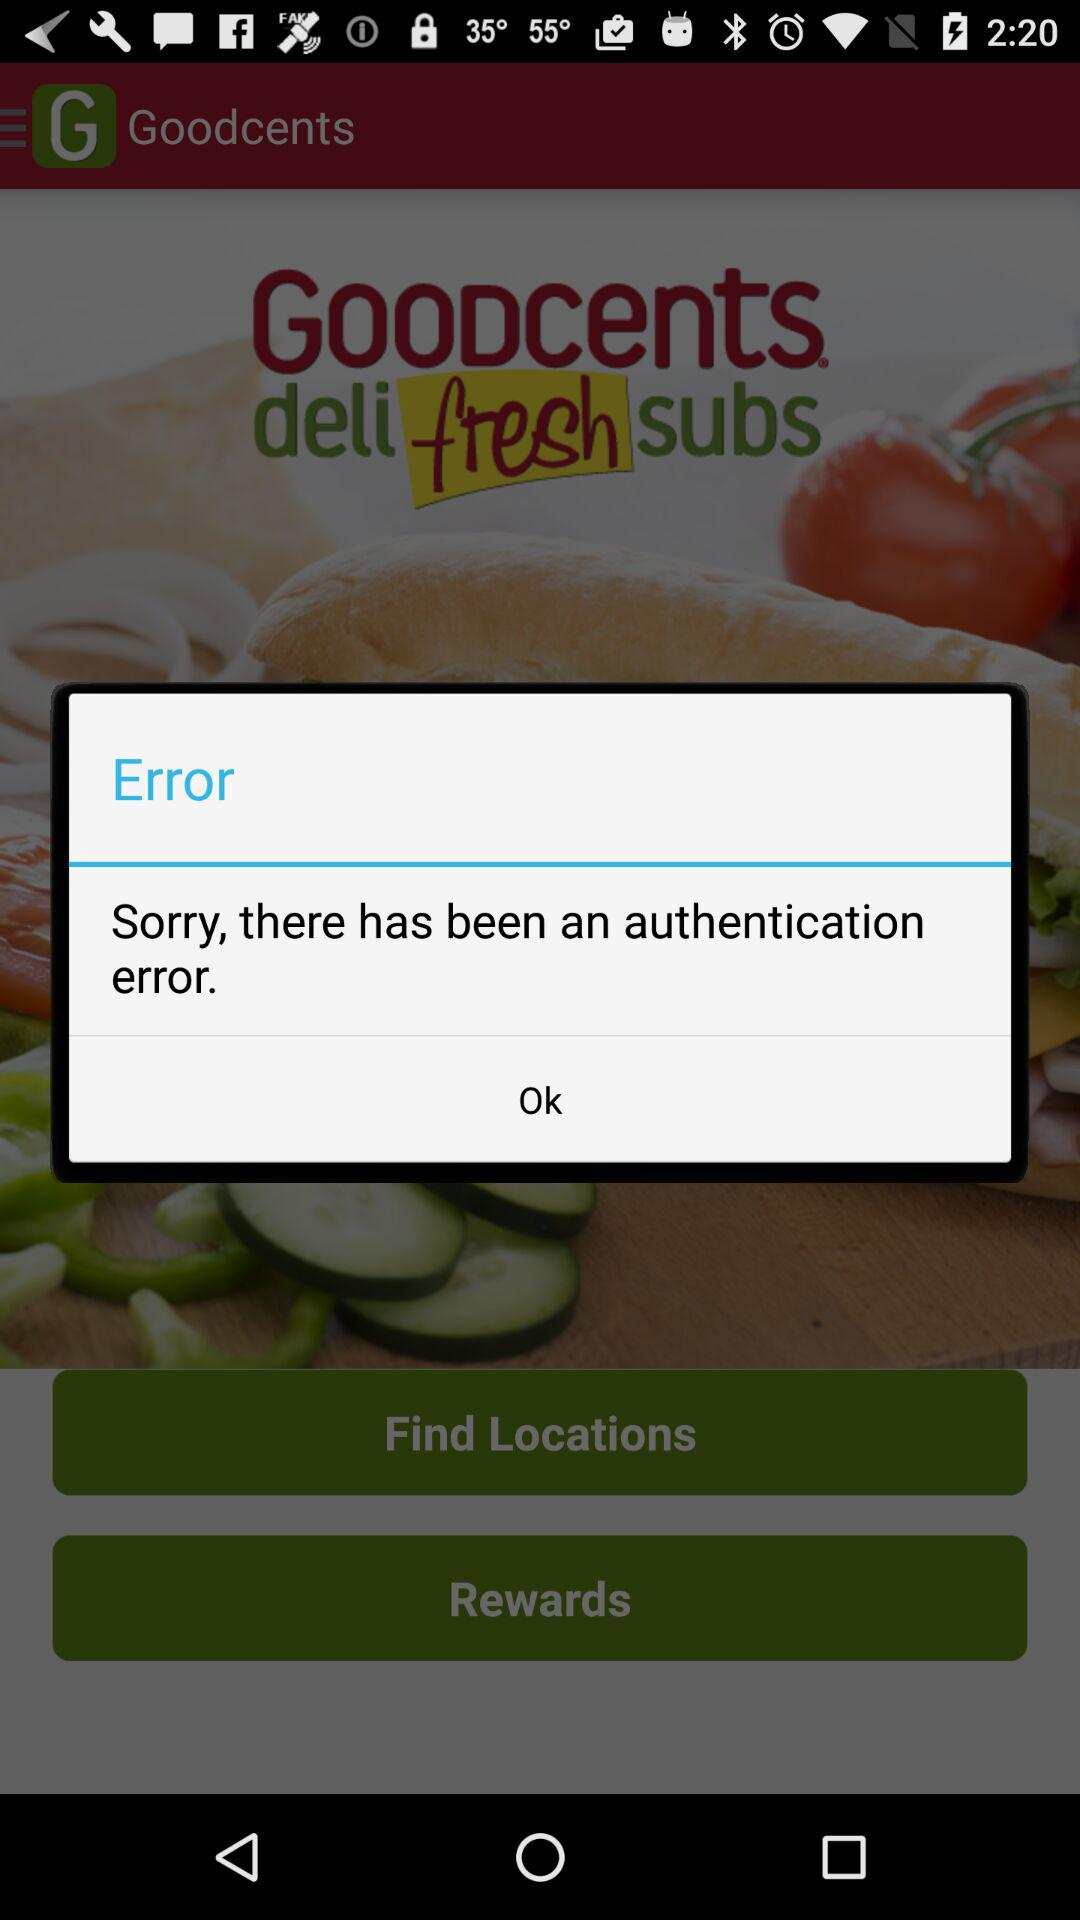What is the name of the application? The name of the application is "Goodcents". 